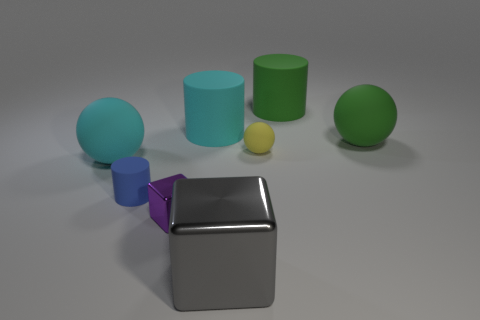There is a ball that is the same size as the purple metal block; what material is it?
Make the answer very short. Rubber. Do the cyan object that is to the right of the blue rubber cylinder and the big green sphere have the same size?
Give a very brief answer. Yes. How many cubes are large red things or small matte objects?
Your response must be concise. 0. What is the material of the ball that is to the left of the yellow matte sphere?
Your answer should be very brief. Rubber. Is the number of small red shiny spheres less than the number of cyan rubber cylinders?
Your answer should be very brief. Yes. What size is the thing that is both in front of the small blue cylinder and behind the gray shiny object?
Make the answer very short. Small. What is the size of the matte thing that is behind the cyan rubber cylinder that is behind the large ball on the left side of the purple metal thing?
Ensure brevity in your answer.  Large. Is the color of the large cylinder to the right of the big gray metallic block the same as the large metal block?
Provide a short and direct response. No. What number of things are either cyan cylinders or metallic objects?
Give a very brief answer. 3. What is the color of the big rubber object in front of the large green matte sphere?
Your response must be concise. Cyan. 